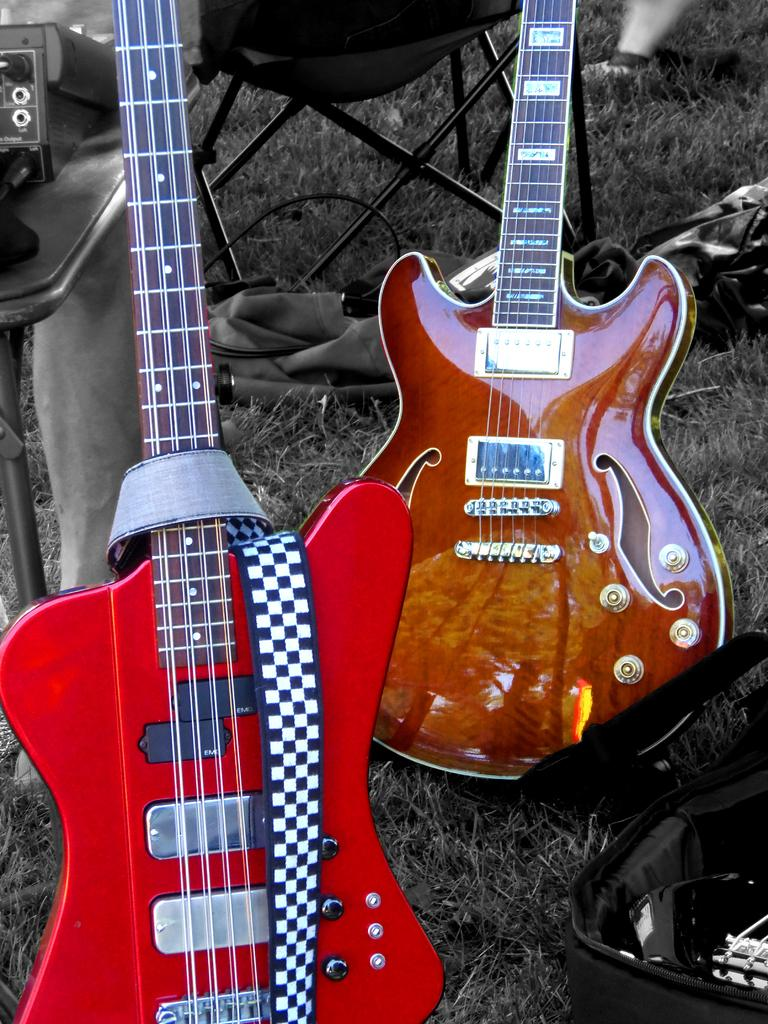How many guitars are in the image? There are two guitars in the image. What are the colors of the guitars? One guitar is red in color, and the other is brown in color. What is the stool's location in the image? The stool is on the grass. What else can be seen on the grass in the image? There are objects on the grass. What type of legal advice is the lawyer providing in the image? There is no lawyer present in the image, so it is not possible to determine what legal advice might be provided. 